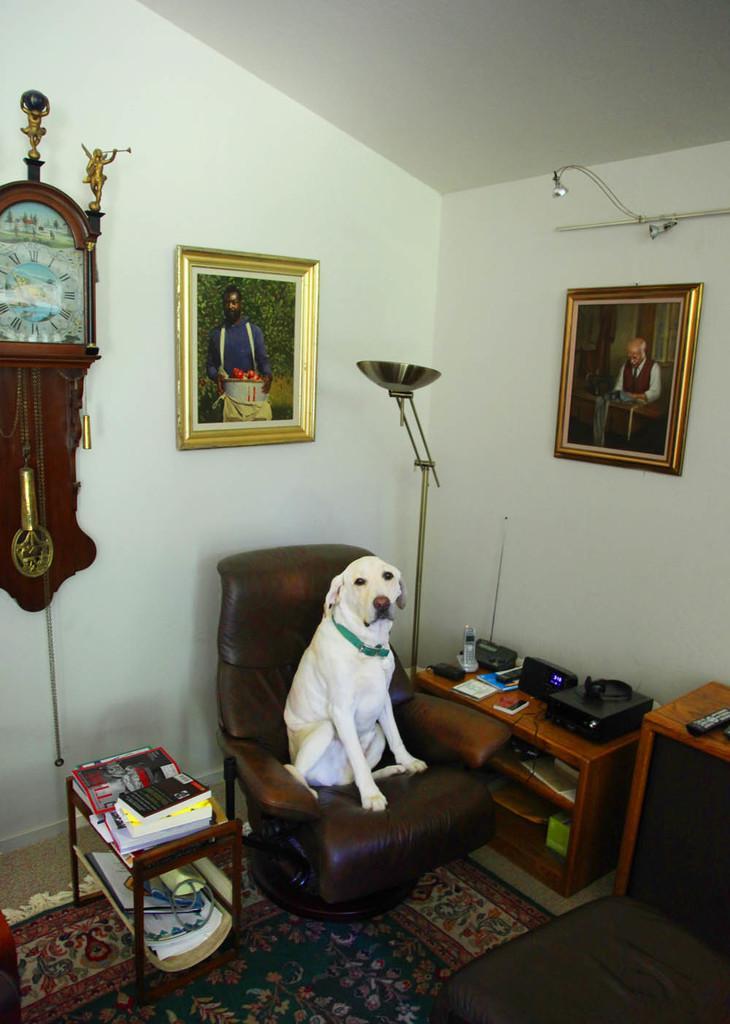How would you summarize this image in a sentence or two? In this image I can see the dog on the chair. The dog is in white color and the chair is in dark brown color. To the side I can see the tables and there are books and many electronic gadgets on it. In the back I can see the wall. To the wall there is a clock and two frames can be seen. 